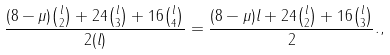Convert formula to latex. <formula><loc_0><loc_0><loc_500><loc_500>\frac { ( 8 - \mu ) { l \choose 2 } + 2 4 { l \choose 3 } + 1 6 { l \choose 4 } } { 2 ( l ) } = \frac { ( 8 - \mu ) l + 2 4 { l \choose 2 } + 1 6 { l \choose 3 } } { 2 } . ,</formula> 